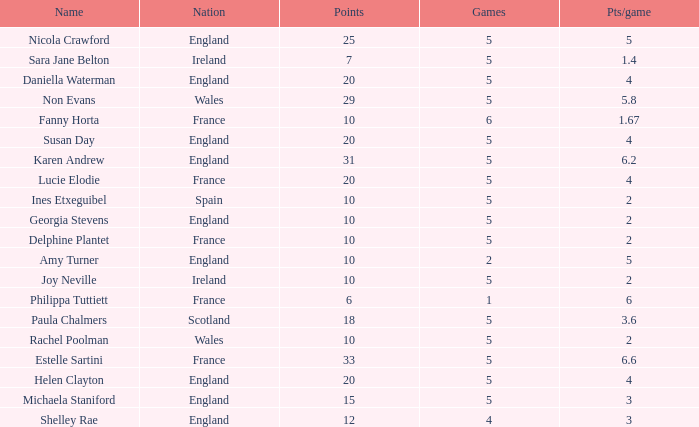Can you tell me the average Points that has a Pts/game larger than 4, and the Nation of england, and the Games smaller than 5? 10.0. 